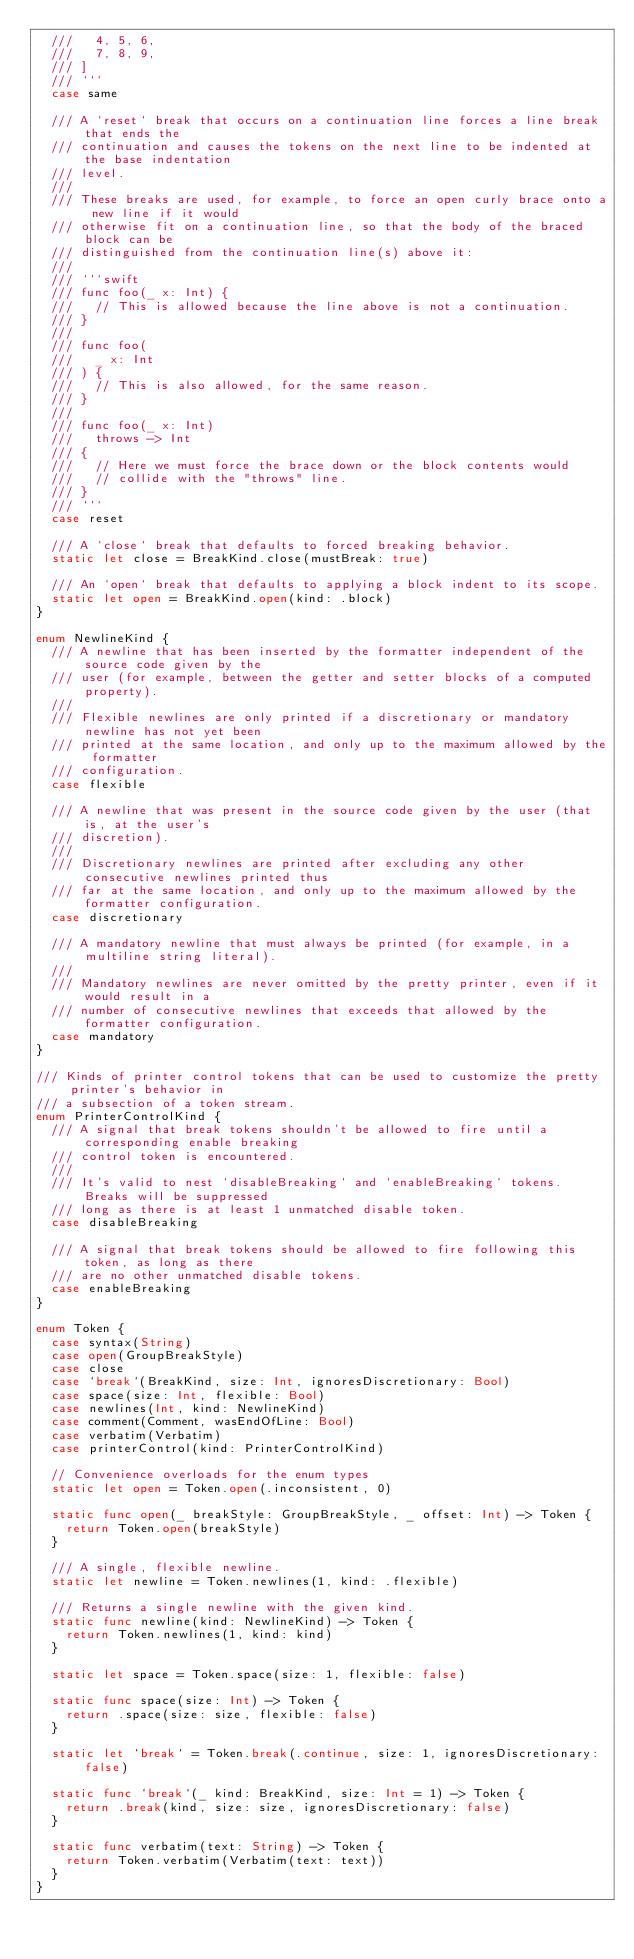<code> <loc_0><loc_0><loc_500><loc_500><_Swift_>  ///   4, 5, 6,
  ///   7, 8, 9,
  /// ]
  /// ```
  case same

  /// A `reset` break that occurs on a continuation line forces a line break that ends the
  /// continuation and causes the tokens on the next line to be indented at the base indentation
  /// level.
  ///
  /// These breaks are used, for example, to force an open curly brace onto a new line if it would
  /// otherwise fit on a continuation line, so that the body of the braced block can be
  /// distinguished from the continuation line(s) above it:
  ///
  /// ```swift
  /// func foo(_ x: Int) {
  ///   // This is allowed because the line above is not a continuation.
  /// }
  ///
  /// func foo(
  ///   _ x: Int
  /// ) {
  ///   // This is also allowed, for the same reason.
  /// }
  ///
  /// func foo(_ x: Int)
  ///   throws -> Int
  /// {
  ///   // Here we must force the brace down or the block contents would
  ///   // collide with the "throws" line.
  /// }
  /// ```
  case reset

  /// A `close` break that defaults to forced breaking behavior.
  static let close = BreakKind.close(mustBreak: true)

  /// An `open` break that defaults to applying a block indent to its scope.
  static let open = BreakKind.open(kind: .block)
}

enum NewlineKind {
  /// A newline that has been inserted by the formatter independent of the source code given by the
  /// user (for example, between the getter and setter blocks of a computed property).
  ///
  /// Flexible newlines are only printed if a discretionary or mandatory newline has not yet been
  /// printed at the same location, and only up to the maximum allowed by the formatter
  /// configuration.
  case flexible

  /// A newline that was present in the source code given by the user (that is, at the user's
  /// discretion).
  ///
  /// Discretionary newlines are printed after excluding any other consecutive newlines printed thus
  /// far at the same location, and only up to the maximum allowed by the formatter configuration.
  case discretionary

  /// A mandatory newline that must always be printed (for example, in a multiline string literal).
  ///
  /// Mandatory newlines are never omitted by the pretty printer, even if it would result in a
  /// number of consecutive newlines that exceeds that allowed by the formatter configuration.
  case mandatory
}

/// Kinds of printer control tokens that can be used to customize the pretty printer's behavior in
/// a subsection of a token stream.
enum PrinterControlKind {
  /// A signal that break tokens shouldn't be allowed to fire until a corresponding enable breaking
  /// control token is encountered.
  ///
  /// It's valid to nest `disableBreaking` and `enableBreaking` tokens. Breaks will be suppressed
  /// long as there is at least 1 unmatched disable token.
  case disableBreaking

  /// A signal that break tokens should be allowed to fire following this token, as long as there
  /// are no other unmatched disable tokens.
  case enableBreaking
}

enum Token {
  case syntax(String)
  case open(GroupBreakStyle)
  case close
  case `break`(BreakKind, size: Int, ignoresDiscretionary: Bool)
  case space(size: Int, flexible: Bool)
  case newlines(Int, kind: NewlineKind)
  case comment(Comment, wasEndOfLine: Bool)
  case verbatim(Verbatim)
  case printerControl(kind: PrinterControlKind)

  // Convenience overloads for the enum types
  static let open = Token.open(.inconsistent, 0)

  static func open(_ breakStyle: GroupBreakStyle, _ offset: Int) -> Token {
    return Token.open(breakStyle)
  }

  /// A single, flexible newline.
  static let newline = Token.newlines(1, kind: .flexible)

  /// Returns a single newline with the given kind.
  static func newline(kind: NewlineKind) -> Token {
    return Token.newlines(1, kind: kind)
  }

  static let space = Token.space(size: 1, flexible: false)

  static func space(size: Int) -> Token {
    return .space(size: size, flexible: false)
  }

  static let `break` = Token.break(.continue, size: 1, ignoresDiscretionary: false)

  static func `break`(_ kind: BreakKind, size: Int = 1) -> Token {
    return .break(kind, size: size, ignoresDiscretionary: false)
  }

  static func verbatim(text: String) -> Token {
    return Token.verbatim(Verbatim(text: text))
  }
}
</code> 